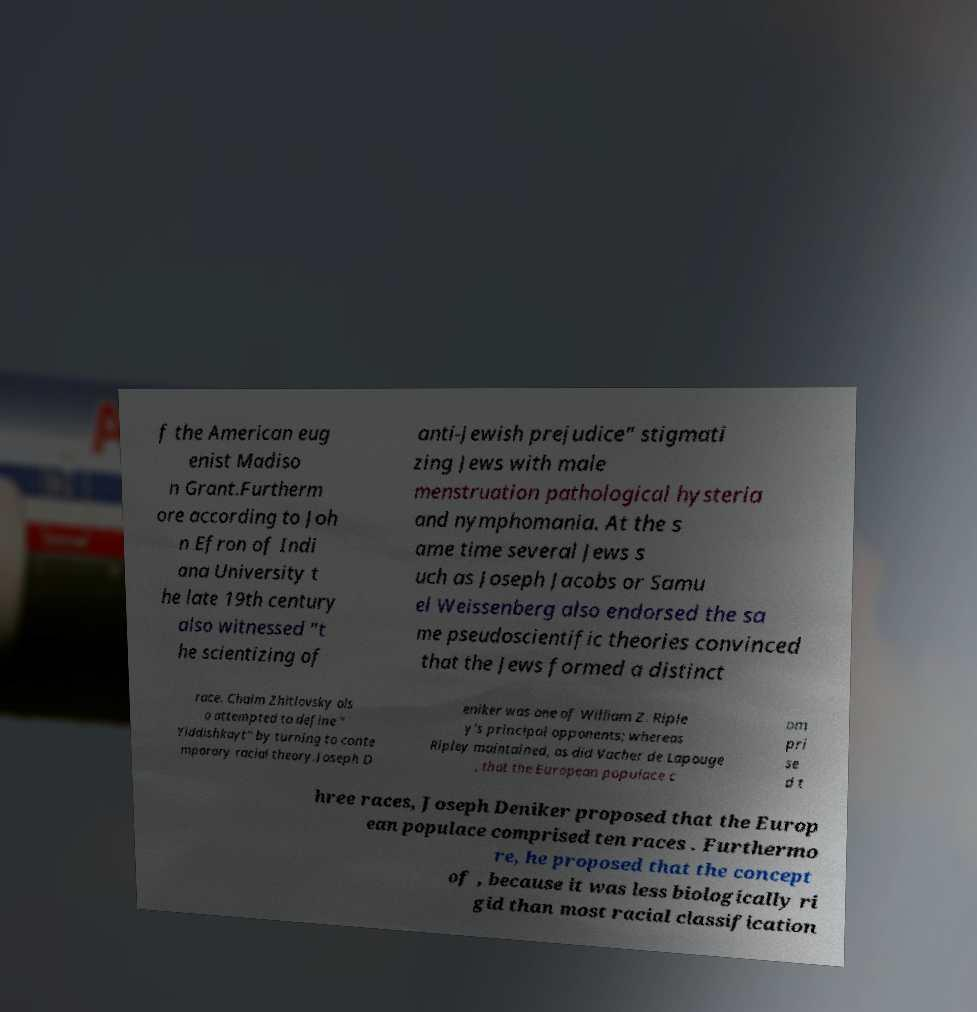What messages or text are displayed in this image? I need them in a readable, typed format. f the American eug enist Madiso n Grant.Furtherm ore according to Joh n Efron of Indi ana University t he late 19th century also witnessed "t he scientizing of anti-Jewish prejudice" stigmati zing Jews with male menstruation pathological hysteria and nymphomania. At the s ame time several Jews s uch as Joseph Jacobs or Samu el Weissenberg also endorsed the sa me pseudoscientific theories convinced that the Jews formed a distinct race. Chaim Zhitlovsky als o attempted to define " Yiddishkayt" by turning to conte mporary racial theory.Joseph D eniker was one of William Z. Riple y's principal opponents; whereas Ripley maintained, as did Vacher de Lapouge , that the European populace c om pri se d t hree races, Joseph Deniker proposed that the Europ ean populace comprised ten races . Furthermo re, he proposed that the concept of , because it was less biologically ri gid than most racial classification 